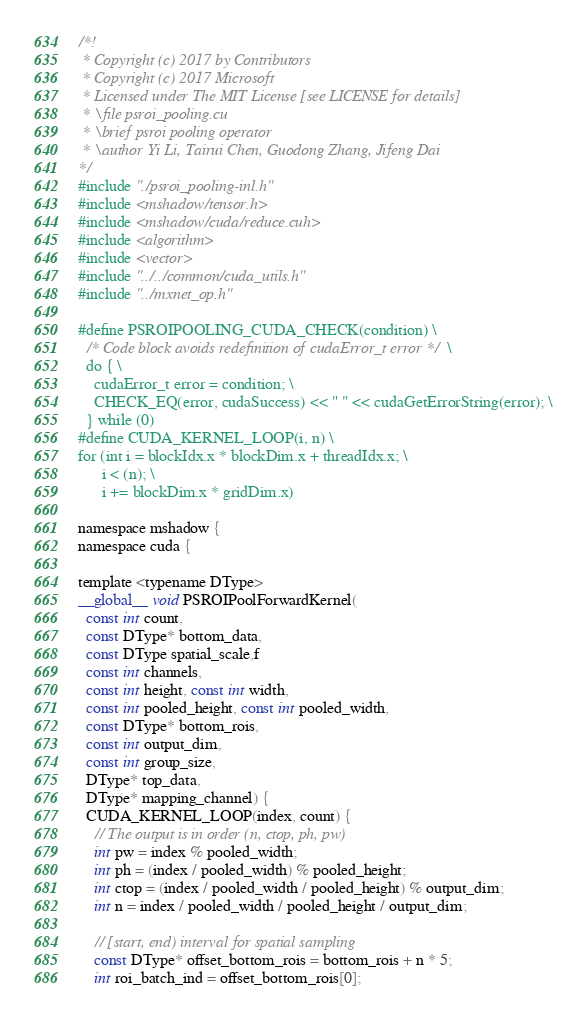<code> <loc_0><loc_0><loc_500><loc_500><_Cuda_>/*!
 * Copyright (c) 2017 by Contributors
 * Copyright (c) 2017 Microsoft
 * Licensed under The MIT License [see LICENSE for details]
 * \file psroi_pooling.cu
 * \brief psroi pooling operator
 * \author Yi Li, Tairui Chen, Guodong Zhang, Jifeng Dai
*/
#include "./psroi_pooling-inl.h"
#include <mshadow/tensor.h>
#include <mshadow/cuda/reduce.cuh>
#include <algorithm>
#include <vector>
#include "../../common/cuda_utils.h"
#include "../mxnet_op.h"

#define PSROIPOOLING_CUDA_CHECK(condition) \
  /* Code block avoids redefinition of cudaError_t error */ \
  do { \
    cudaError_t error = condition; \
    CHECK_EQ(error, cudaSuccess) << " " << cudaGetErrorString(error); \
  } while (0)
#define CUDA_KERNEL_LOOP(i, n) \
for (int i = blockIdx.x * blockDim.x + threadIdx.x; \
      i < (n); \
      i += blockDim.x * gridDim.x)

namespace mshadow {
namespace cuda {

template <typename DType>
__global__ void PSROIPoolForwardKernel(
  const int count,
  const DType* bottom_data,
  const DType spatial_scale,f
  const int channels,
  const int height, const int width,
  const int pooled_height, const int pooled_width,
  const DType* bottom_rois,
  const int output_dim,
  const int group_size,
  DType* top_data,
  DType* mapping_channel) {
  CUDA_KERNEL_LOOP(index, count) {
    // The output is in order (n, ctop, ph, pw)
    int pw = index % pooled_width;
    int ph = (index / pooled_width) % pooled_height;
    int ctop = (index / pooled_width / pooled_height) % output_dim;
    int n = index / pooled_width / pooled_height / output_dim;

    // [start, end) interval for spatial sampling
    const DType* offset_bottom_rois = bottom_rois + n * 5;
    int roi_batch_ind = offset_bottom_rois[0];</code> 